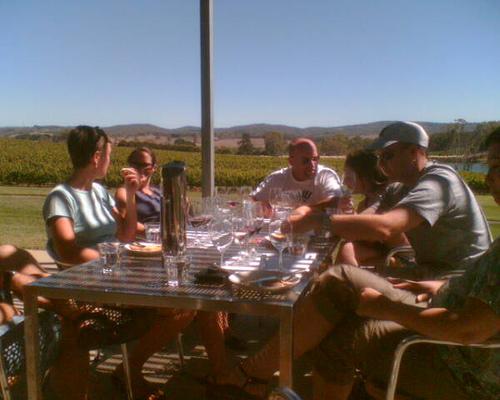Is there a body of water in the background?
Be succinct. Yes. Is this a family having a party?
Answer briefly. Yes. Is this a family gathering?
Concise answer only. Yes. 